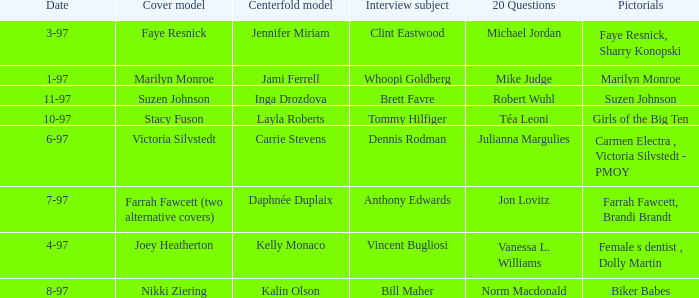When was Kalin Olson listed as  the centerfold model? 8-97. Write the full table. {'header': ['Date', 'Cover model', 'Centerfold model', 'Interview subject', '20 Questions', 'Pictorials'], 'rows': [['3-97', 'Faye Resnick', 'Jennifer Miriam', 'Clint Eastwood', 'Michael Jordan', 'Faye Resnick, Sharry Konopski'], ['1-97', 'Marilyn Monroe', 'Jami Ferrell', 'Whoopi Goldberg', 'Mike Judge', 'Marilyn Monroe'], ['11-97', 'Suzen Johnson', 'Inga Drozdova', 'Brett Favre', 'Robert Wuhl', 'Suzen Johnson'], ['10-97', 'Stacy Fuson', 'Layla Roberts', 'Tommy Hilfiger', 'Téa Leoni', 'Girls of the Big Ten'], ['6-97', 'Victoria Silvstedt', 'Carrie Stevens', 'Dennis Rodman', 'Julianna Margulies', 'Carmen Electra , Victoria Silvstedt - PMOY'], ['7-97', 'Farrah Fawcett (two alternative covers)', 'Daphnée Duplaix', 'Anthony Edwards', 'Jon Lovitz', 'Farrah Fawcett, Brandi Brandt'], ['4-97', 'Joey Heatherton', 'Kelly Monaco', 'Vincent Bugliosi', 'Vanessa L. Williams', 'Female s dentist , Dolly Martin'], ['8-97', 'Nikki Ziering', 'Kalin Olson', 'Bill Maher', 'Norm Macdonald', 'Biker Babes']]} 